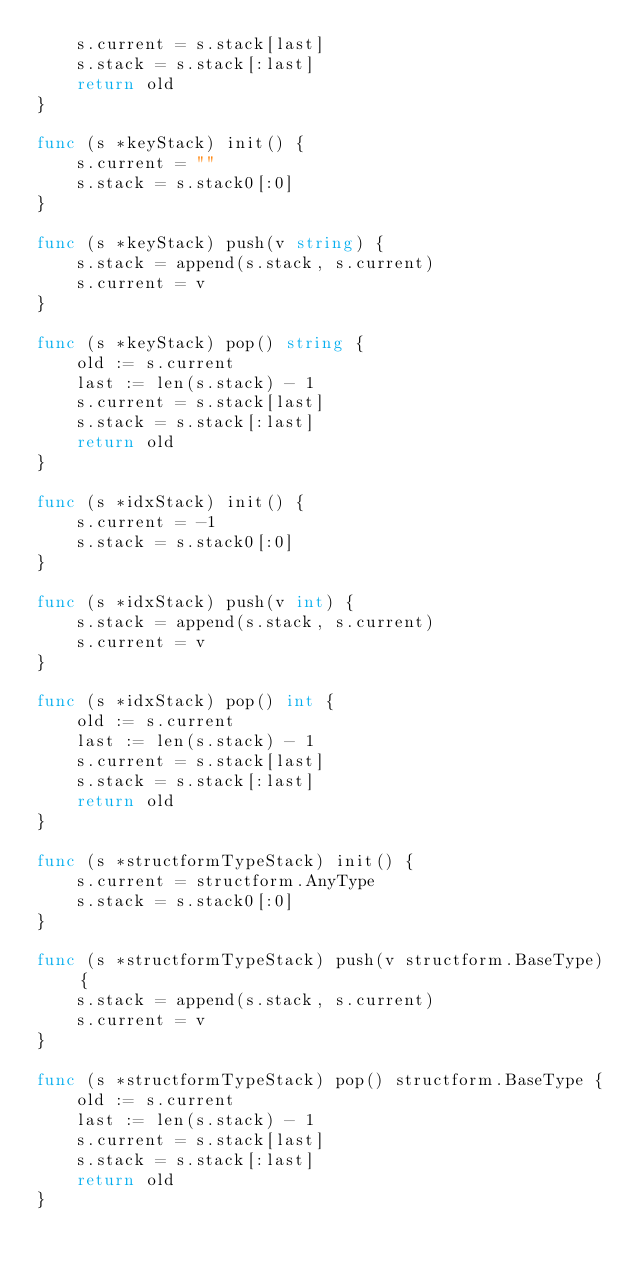Convert code to text. <code><loc_0><loc_0><loc_500><loc_500><_Go_>	s.current = s.stack[last]
	s.stack = s.stack[:last]
	return old
}

func (s *keyStack) init() {
	s.current = ""
	s.stack = s.stack0[:0]
}

func (s *keyStack) push(v string) {
	s.stack = append(s.stack, s.current)
	s.current = v
}

func (s *keyStack) pop() string {
	old := s.current
	last := len(s.stack) - 1
	s.current = s.stack[last]
	s.stack = s.stack[:last]
	return old
}

func (s *idxStack) init() {
	s.current = -1
	s.stack = s.stack0[:0]
}

func (s *idxStack) push(v int) {
	s.stack = append(s.stack, s.current)
	s.current = v
}

func (s *idxStack) pop() int {
	old := s.current
	last := len(s.stack) - 1
	s.current = s.stack[last]
	s.stack = s.stack[:last]
	return old
}

func (s *structformTypeStack) init() {
	s.current = structform.AnyType
	s.stack = s.stack0[:0]
}

func (s *structformTypeStack) push(v structform.BaseType) {
	s.stack = append(s.stack, s.current)
	s.current = v
}

func (s *structformTypeStack) pop() structform.BaseType {
	old := s.current
	last := len(s.stack) - 1
	s.current = s.stack[last]
	s.stack = s.stack[:last]
	return old
}
</code> 